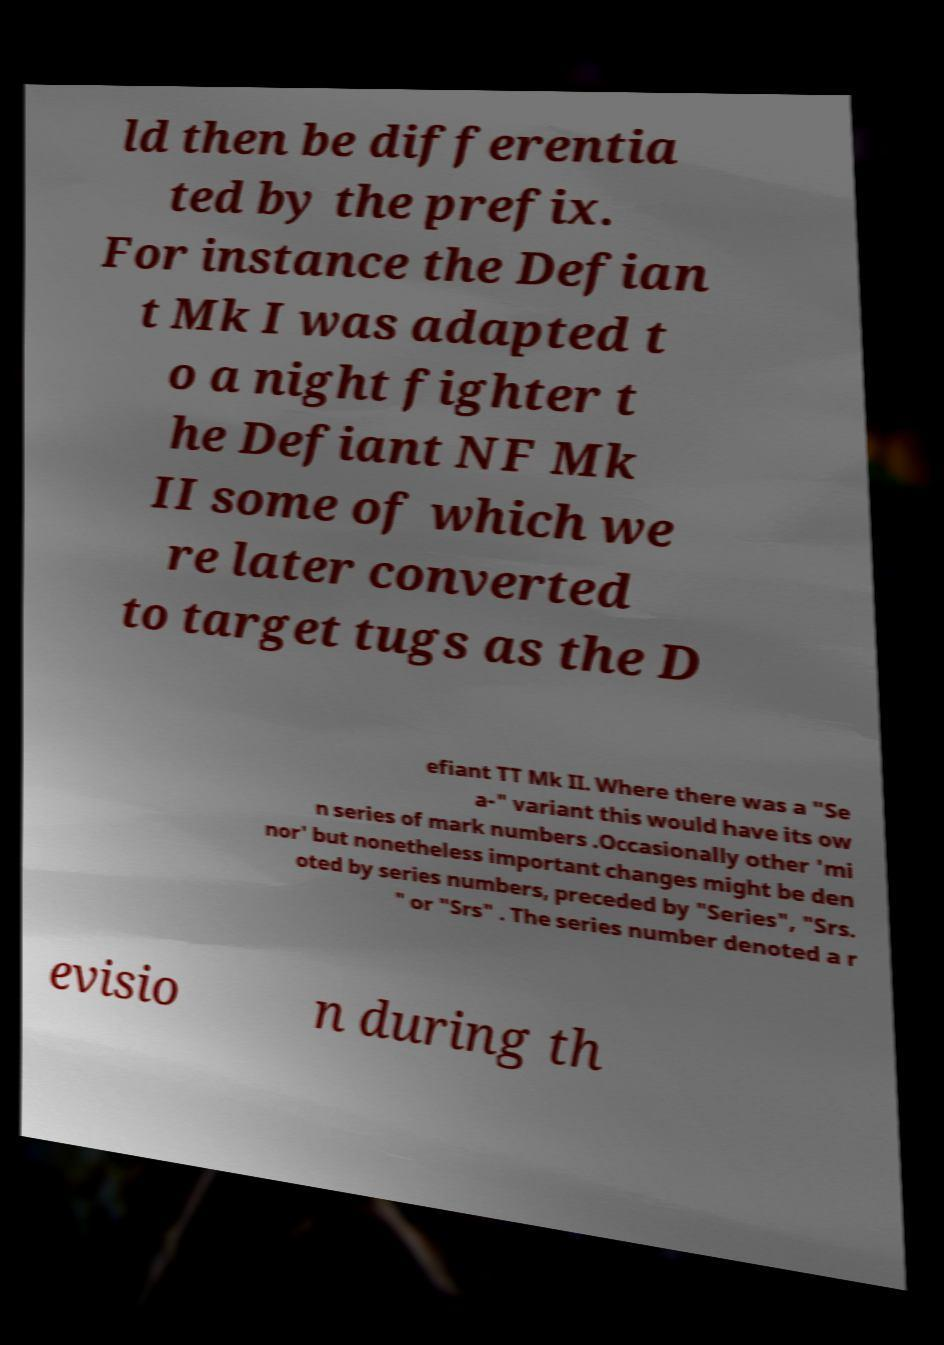Could you assist in decoding the text presented in this image and type it out clearly? ld then be differentia ted by the prefix. For instance the Defian t Mk I was adapted t o a night fighter t he Defiant NF Mk II some of which we re later converted to target tugs as the D efiant TT Mk II. Where there was a "Se a-" variant this would have its ow n series of mark numbers .Occasionally other 'mi nor' but nonetheless important changes might be den oted by series numbers, preceded by "Series", "Srs. " or "Srs" . The series number denoted a r evisio n during th 